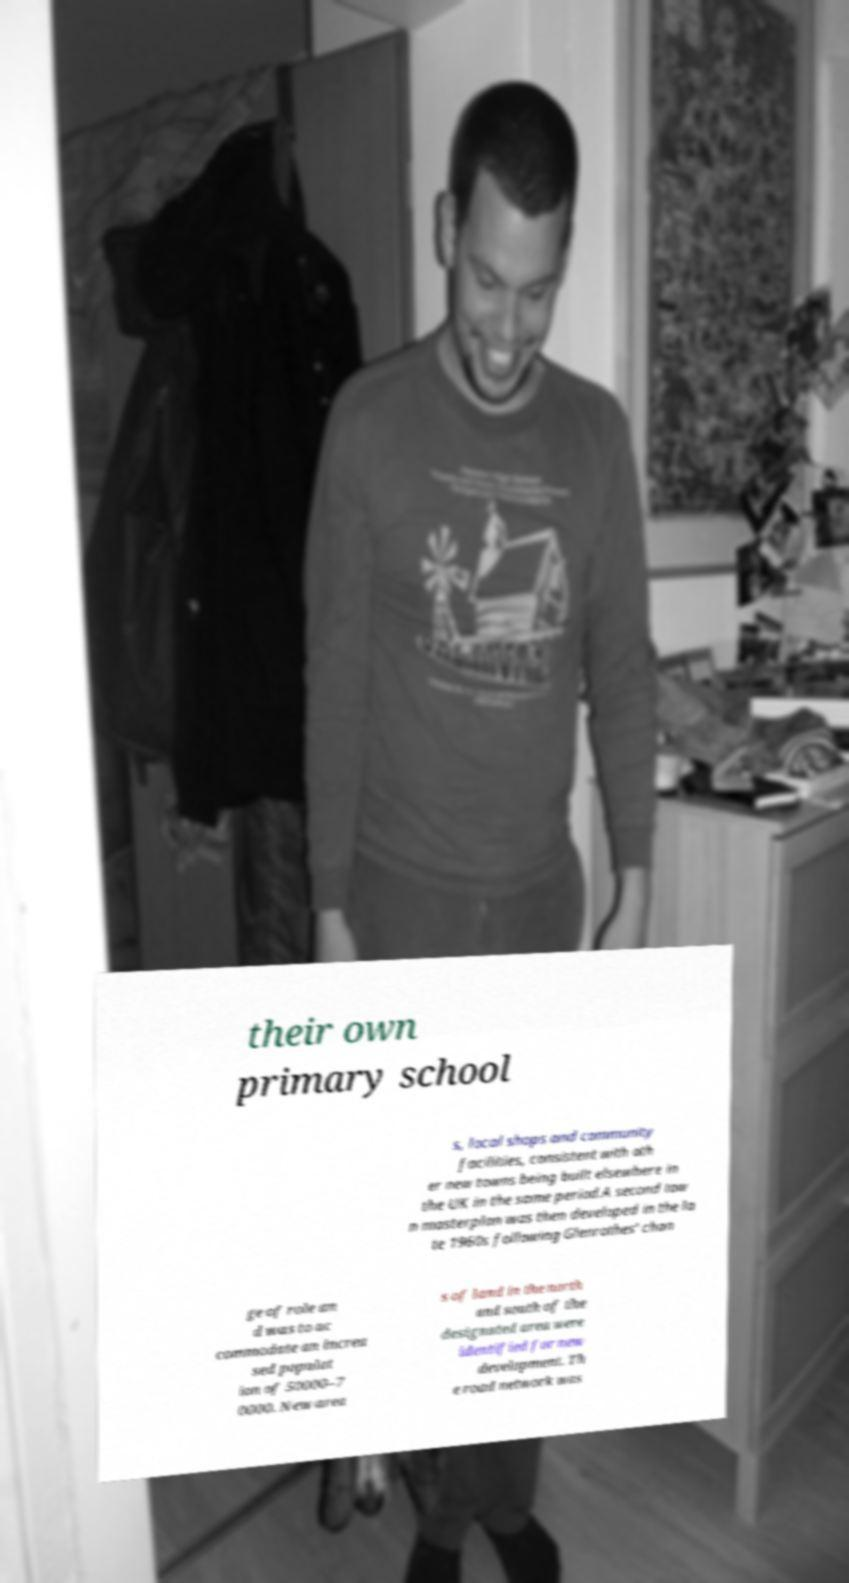For documentation purposes, I need the text within this image transcribed. Could you provide that? their own primary school s, local shops and community facilities, consistent with oth er new towns being built elsewhere in the UK in the same period.A second tow n masterplan was then developed in the la te 1960s following Glenrothes' chan ge of role an d was to ac commodate an increa sed populat ion of 50000–7 0000. New area s of land in the north and south of the designated area were identified for new development. Th e road network was 